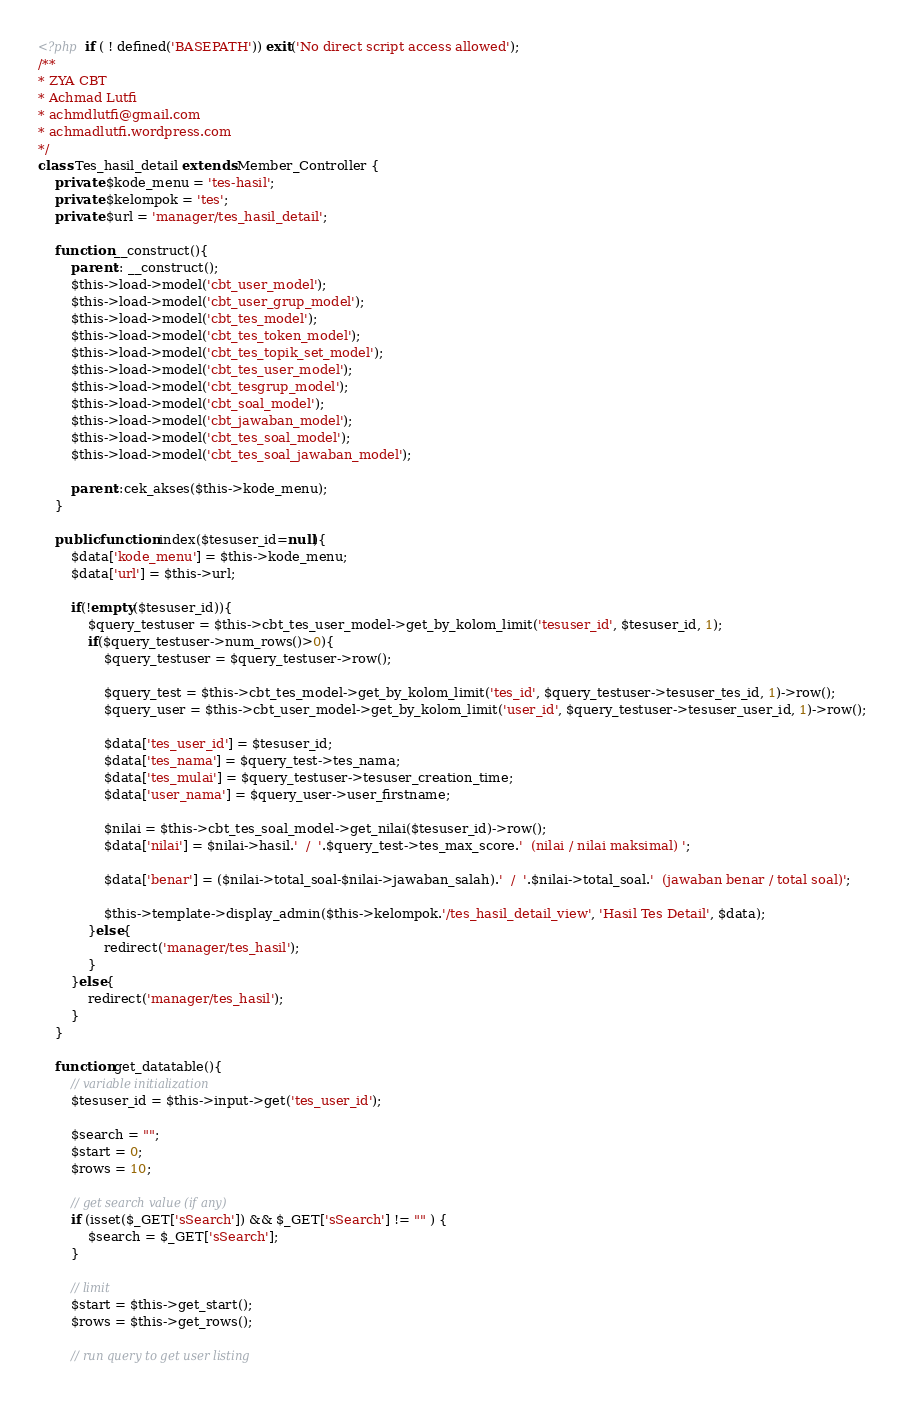Convert code to text. <code><loc_0><loc_0><loc_500><loc_500><_PHP_><?php if ( ! defined('BASEPATH')) exit('No direct script access allowed');
/**
* ZYA CBT
* Achmad Lutfi
* achmdlutfi@gmail.com
* achmadlutfi.wordpress.com
*/
class Tes_hasil_detail extends Member_Controller {
	private $kode_menu = 'tes-hasil';
	private $kelompok = 'tes';
	private $url = 'manager/tes_hasil_detail';
	
    function __construct(){
		parent:: __construct();
		$this->load->model('cbt_user_model');
		$this->load->model('cbt_user_grup_model');
		$this->load->model('cbt_tes_model');
		$this->load->model('cbt_tes_token_model');
		$this->load->model('cbt_tes_topik_set_model');
		$this->load->model('cbt_tes_user_model');
		$this->load->model('cbt_tesgrup_model');
		$this->load->model('cbt_soal_model');
		$this->load->model('cbt_jawaban_model');
		$this->load->model('cbt_tes_soal_model');
		$this->load->model('cbt_tes_soal_jawaban_model');

		parent::cek_akses($this->kode_menu);
	}
	
    public function index($tesuser_id=null){
        $data['kode_menu'] = $this->kode_menu;
        $data['url'] = $this->url;

        if(!empty($tesuser_id)){
        	$query_testuser = $this->cbt_tes_user_model->get_by_kolom_limit('tesuser_id', $tesuser_id, 1);
        	if($query_testuser->num_rows()>0){
        		$query_testuser = $query_testuser->row();

        		$query_test = $this->cbt_tes_model->get_by_kolom_limit('tes_id', $query_testuser->tesuser_tes_id, 1)->row();
        		$query_user = $this->cbt_user_model->get_by_kolom_limit('user_id', $query_testuser->tesuser_user_id, 1)->row();

        		$data['tes_user_id'] = $tesuser_id;
        		$data['tes_nama'] = $query_test->tes_nama;
        		$data['tes_mulai'] = $query_testuser->tesuser_creation_time;
        		$data['user_nama'] = $query_user->user_firstname;

        		$nilai = $this->cbt_tes_soal_model->get_nilai($tesuser_id)->row();
        		$data['nilai'] = $nilai->hasil.'  /  '.$query_test->tes_max_score.'  (nilai / nilai maksimal) ';

        		$data['benar'] = ($nilai->total_soal-$nilai->jawaban_salah).'  /  '.$nilai->total_soal.'  (jawaban benar / total soal)';

        		$this->template->display_admin($this->kelompok.'/tes_hasil_detail_view', 'Hasil Tes Detail', $data);
        	}else{
        		redirect('manager/tes_hasil');	
        	}
        }else{
        	redirect('manager/tes_hasil');
        }
    }
    
    function get_datatable(){
		// variable initialization
		$tesuser_id = $this->input->get('tes_user_id');

		$search = "";
		$start = 0;
		$rows = 10;

		// get search value (if any)
		if (isset($_GET['sSearch']) && $_GET['sSearch'] != "" ) {
			$search = $_GET['sSearch'];
		}

		// limit
		$start = $this->get_start();
		$rows = $this->get_rows();

		// run query to get user listing</code> 